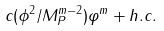<formula> <loc_0><loc_0><loc_500><loc_500>c ( \phi ^ { 2 } / M _ { P } ^ { m - 2 } ) \varphi ^ { m } + h . c .</formula> 